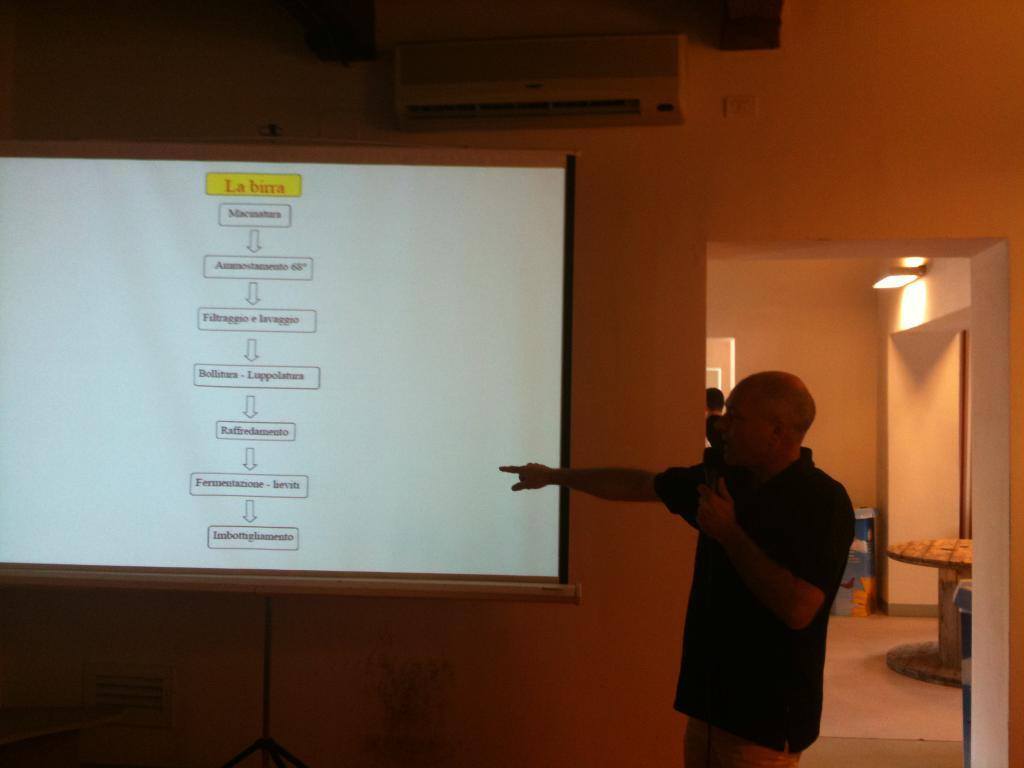<image>
Describe the image concisely. The power point is in a language that is not English. 